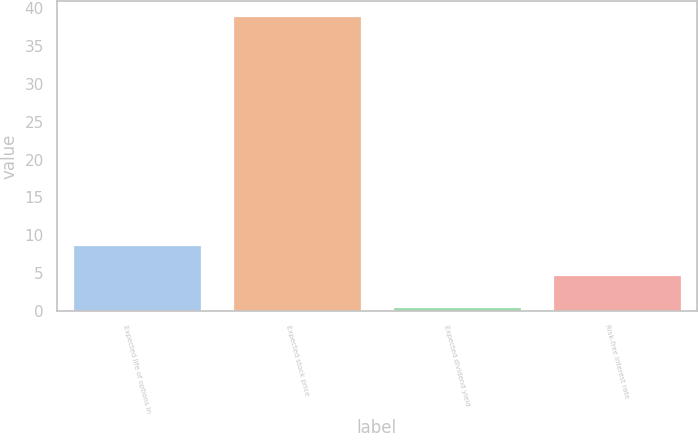Convert chart. <chart><loc_0><loc_0><loc_500><loc_500><bar_chart><fcel>Expected life of options in<fcel>Expected stock price<fcel>Expected dividend yield<fcel>Risk-free interest rate<nl><fcel>8.65<fcel>39<fcel>0.5<fcel>4.8<nl></chart> 